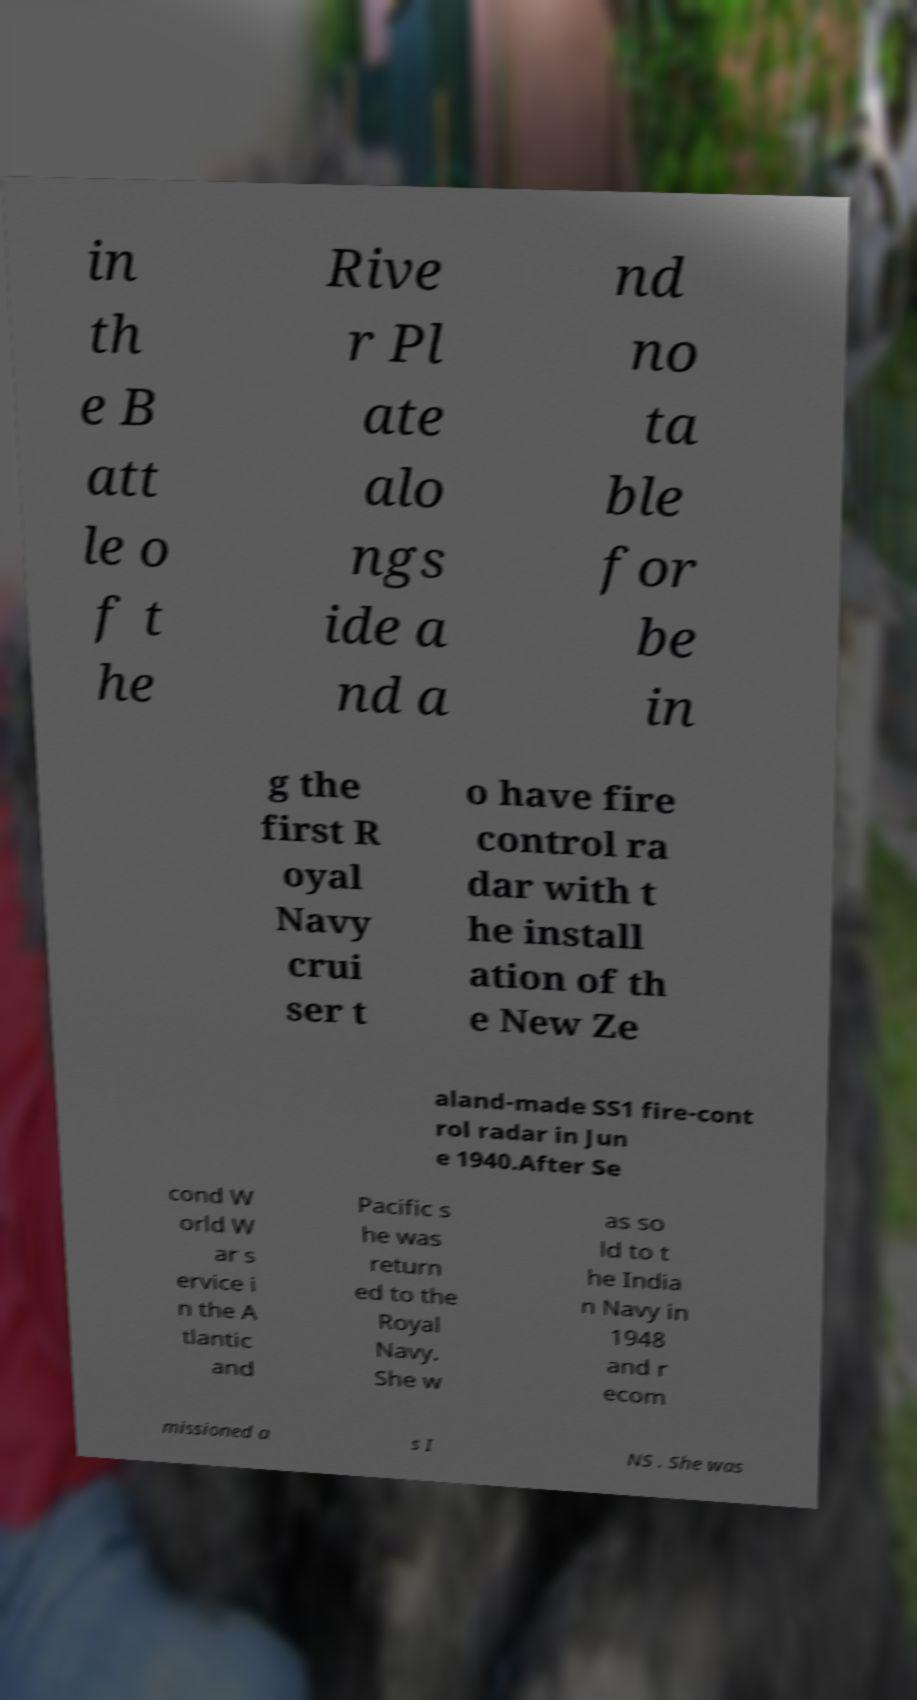Could you extract and type out the text from this image? in th e B att le o f t he Rive r Pl ate alo ngs ide a nd a nd no ta ble for be in g the first R oyal Navy crui ser t o have fire control ra dar with t he install ation of th e New Ze aland-made SS1 fire-cont rol radar in Jun e 1940.After Se cond W orld W ar s ervice i n the A tlantic and Pacific s he was return ed to the Royal Navy. She w as so ld to t he India n Navy in 1948 and r ecom missioned a s I NS . She was 